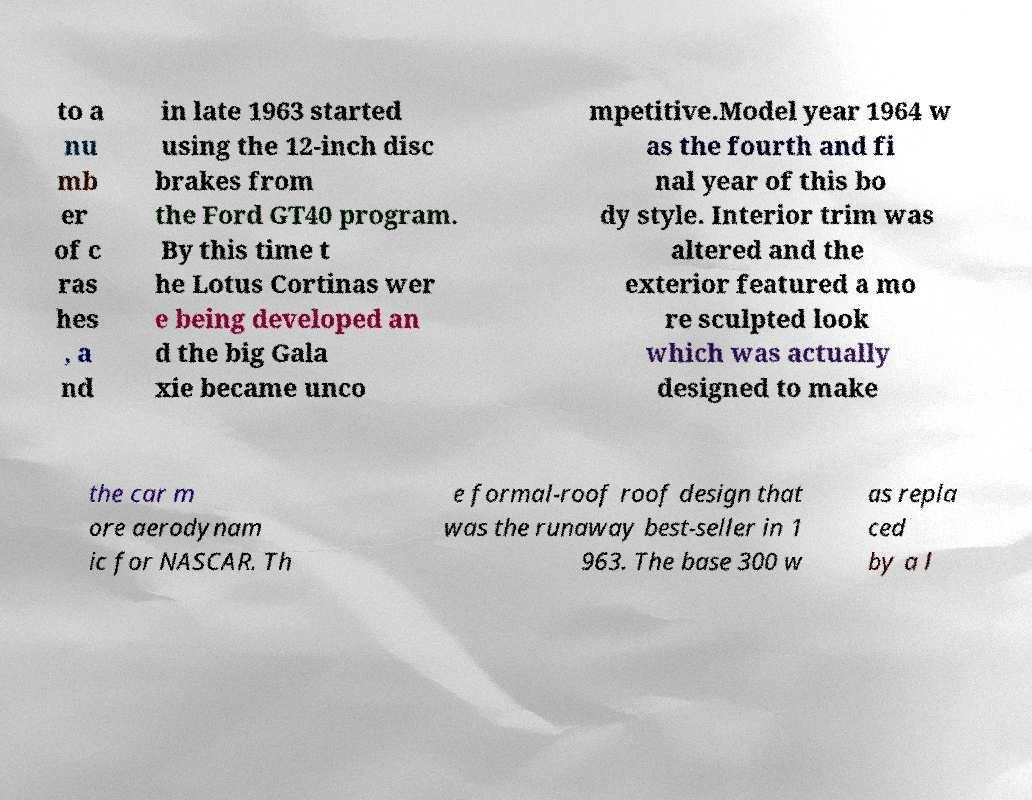For documentation purposes, I need the text within this image transcribed. Could you provide that? to a nu mb er of c ras hes , a nd in late 1963 started using the 12-inch disc brakes from the Ford GT40 program. By this time t he Lotus Cortinas wer e being developed an d the big Gala xie became unco mpetitive.Model year 1964 w as the fourth and fi nal year of this bo dy style. Interior trim was altered and the exterior featured a mo re sculpted look which was actually designed to make the car m ore aerodynam ic for NASCAR. Th e formal-roof roof design that was the runaway best-seller in 1 963. The base 300 w as repla ced by a l 